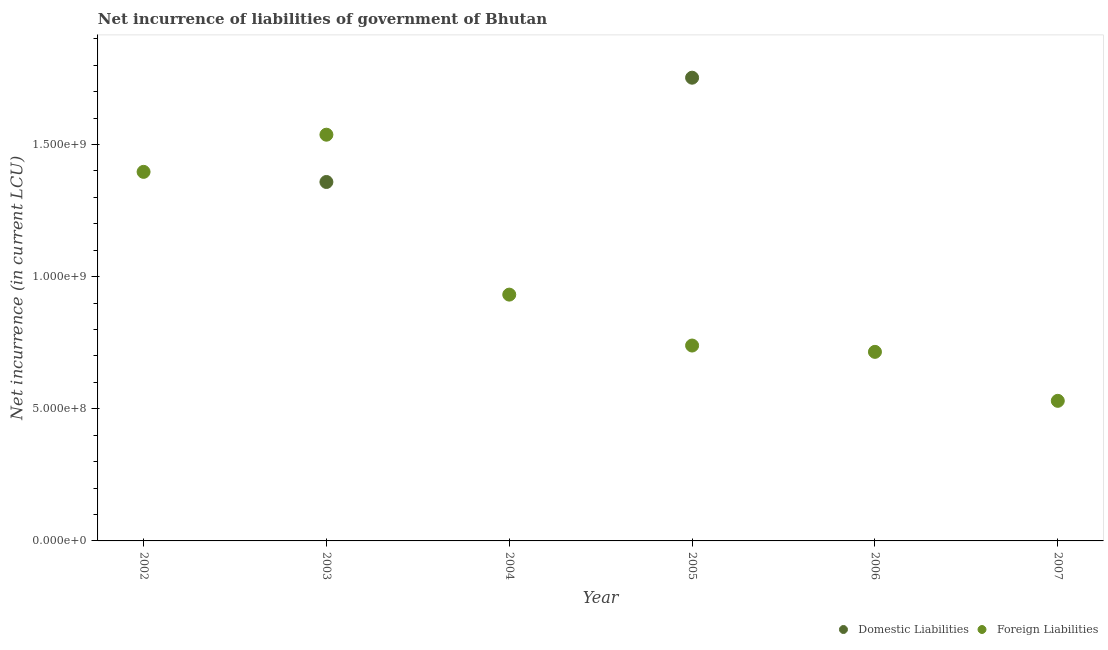How many different coloured dotlines are there?
Offer a very short reply. 2. Is the number of dotlines equal to the number of legend labels?
Offer a very short reply. No. Across all years, what is the maximum net incurrence of domestic liabilities?
Your answer should be compact. 1.75e+09. Across all years, what is the minimum net incurrence of foreign liabilities?
Your answer should be very brief. 5.30e+08. What is the total net incurrence of foreign liabilities in the graph?
Your answer should be compact. 5.85e+09. What is the difference between the net incurrence of foreign liabilities in 2003 and that in 2006?
Make the answer very short. 8.22e+08. What is the difference between the net incurrence of domestic liabilities in 2002 and the net incurrence of foreign liabilities in 2005?
Offer a terse response. -7.39e+08. What is the average net incurrence of foreign liabilities per year?
Keep it short and to the point. 9.75e+08. In the year 2003, what is the difference between the net incurrence of domestic liabilities and net incurrence of foreign liabilities?
Your response must be concise. -1.79e+08. In how many years, is the net incurrence of domestic liabilities greater than 700000000 LCU?
Provide a short and direct response. 2. What is the ratio of the net incurrence of foreign liabilities in 2004 to that in 2005?
Ensure brevity in your answer.  1.26. What is the difference between the highest and the second highest net incurrence of foreign liabilities?
Keep it short and to the point. 1.41e+08. What is the difference between the highest and the lowest net incurrence of domestic liabilities?
Keep it short and to the point. 1.75e+09. In how many years, is the net incurrence of foreign liabilities greater than the average net incurrence of foreign liabilities taken over all years?
Your answer should be compact. 2. Is the sum of the net incurrence of foreign liabilities in 2003 and 2004 greater than the maximum net incurrence of domestic liabilities across all years?
Offer a very short reply. Yes. Are the values on the major ticks of Y-axis written in scientific E-notation?
Make the answer very short. Yes. Does the graph contain grids?
Your response must be concise. No. What is the title of the graph?
Keep it short and to the point. Net incurrence of liabilities of government of Bhutan. Does "Female" appear as one of the legend labels in the graph?
Your response must be concise. No. What is the label or title of the Y-axis?
Your answer should be very brief. Net incurrence (in current LCU). What is the Net incurrence (in current LCU) in Foreign Liabilities in 2002?
Your response must be concise. 1.40e+09. What is the Net incurrence (in current LCU) in Domestic Liabilities in 2003?
Your answer should be compact. 1.36e+09. What is the Net incurrence (in current LCU) in Foreign Liabilities in 2003?
Your response must be concise. 1.54e+09. What is the Net incurrence (in current LCU) in Foreign Liabilities in 2004?
Ensure brevity in your answer.  9.32e+08. What is the Net incurrence (in current LCU) in Domestic Liabilities in 2005?
Provide a succinct answer. 1.75e+09. What is the Net incurrence (in current LCU) of Foreign Liabilities in 2005?
Your response must be concise. 7.39e+08. What is the Net incurrence (in current LCU) in Foreign Liabilities in 2006?
Your answer should be compact. 7.15e+08. What is the Net incurrence (in current LCU) of Domestic Liabilities in 2007?
Offer a terse response. 0. What is the Net incurrence (in current LCU) of Foreign Liabilities in 2007?
Your answer should be compact. 5.30e+08. Across all years, what is the maximum Net incurrence (in current LCU) of Domestic Liabilities?
Provide a short and direct response. 1.75e+09. Across all years, what is the maximum Net incurrence (in current LCU) of Foreign Liabilities?
Your response must be concise. 1.54e+09. Across all years, what is the minimum Net incurrence (in current LCU) in Domestic Liabilities?
Provide a short and direct response. 0. Across all years, what is the minimum Net incurrence (in current LCU) in Foreign Liabilities?
Provide a succinct answer. 5.30e+08. What is the total Net incurrence (in current LCU) of Domestic Liabilities in the graph?
Ensure brevity in your answer.  3.11e+09. What is the total Net incurrence (in current LCU) of Foreign Liabilities in the graph?
Give a very brief answer. 5.85e+09. What is the difference between the Net incurrence (in current LCU) of Foreign Liabilities in 2002 and that in 2003?
Give a very brief answer. -1.41e+08. What is the difference between the Net incurrence (in current LCU) of Foreign Liabilities in 2002 and that in 2004?
Offer a terse response. 4.65e+08. What is the difference between the Net incurrence (in current LCU) of Foreign Liabilities in 2002 and that in 2005?
Your answer should be very brief. 6.57e+08. What is the difference between the Net incurrence (in current LCU) in Foreign Liabilities in 2002 and that in 2006?
Provide a short and direct response. 6.81e+08. What is the difference between the Net incurrence (in current LCU) in Foreign Liabilities in 2002 and that in 2007?
Your answer should be very brief. 8.67e+08. What is the difference between the Net incurrence (in current LCU) of Foreign Liabilities in 2003 and that in 2004?
Your answer should be compact. 6.05e+08. What is the difference between the Net incurrence (in current LCU) of Domestic Liabilities in 2003 and that in 2005?
Your answer should be very brief. -3.95e+08. What is the difference between the Net incurrence (in current LCU) in Foreign Liabilities in 2003 and that in 2005?
Your response must be concise. 7.98e+08. What is the difference between the Net incurrence (in current LCU) in Foreign Liabilities in 2003 and that in 2006?
Provide a short and direct response. 8.22e+08. What is the difference between the Net incurrence (in current LCU) in Foreign Liabilities in 2003 and that in 2007?
Make the answer very short. 1.01e+09. What is the difference between the Net incurrence (in current LCU) of Foreign Liabilities in 2004 and that in 2005?
Keep it short and to the point. 1.93e+08. What is the difference between the Net incurrence (in current LCU) in Foreign Liabilities in 2004 and that in 2006?
Provide a succinct answer. 2.17e+08. What is the difference between the Net incurrence (in current LCU) of Foreign Liabilities in 2004 and that in 2007?
Your answer should be compact. 4.02e+08. What is the difference between the Net incurrence (in current LCU) of Foreign Liabilities in 2005 and that in 2006?
Provide a succinct answer. 2.39e+07. What is the difference between the Net incurrence (in current LCU) in Foreign Liabilities in 2005 and that in 2007?
Your response must be concise. 2.09e+08. What is the difference between the Net incurrence (in current LCU) in Foreign Liabilities in 2006 and that in 2007?
Keep it short and to the point. 1.85e+08. What is the difference between the Net incurrence (in current LCU) of Domestic Liabilities in 2003 and the Net incurrence (in current LCU) of Foreign Liabilities in 2004?
Keep it short and to the point. 4.26e+08. What is the difference between the Net incurrence (in current LCU) in Domestic Liabilities in 2003 and the Net incurrence (in current LCU) in Foreign Liabilities in 2005?
Provide a short and direct response. 6.19e+08. What is the difference between the Net incurrence (in current LCU) in Domestic Liabilities in 2003 and the Net incurrence (in current LCU) in Foreign Liabilities in 2006?
Provide a succinct answer. 6.43e+08. What is the difference between the Net incurrence (in current LCU) in Domestic Liabilities in 2003 and the Net incurrence (in current LCU) in Foreign Liabilities in 2007?
Offer a terse response. 8.28e+08. What is the difference between the Net incurrence (in current LCU) in Domestic Liabilities in 2005 and the Net incurrence (in current LCU) in Foreign Liabilities in 2006?
Give a very brief answer. 1.04e+09. What is the difference between the Net incurrence (in current LCU) of Domestic Liabilities in 2005 and the Net incurrence (in current LCU) of Foreign Liabilities in 2007?
Make the answer very short. 1.22e+09. What is the average Net incurrence (in current LCU) of Domestic Liabilities per year?
Your answer should be very brief. 5.19e+08. What is the average Net incurrence (in current LCU) of Foreign Liabilities per year?
Provide a succinct answer. 9.75e+08. In the year 2003, what is the difference between the Net incurrence (in current LCU) in Domestic Liabilities and Net incurrence (in current LCU) in Foreign Liabilities?
Offer a terse response. -1.79e+08. In the year 2005, what is the difference between the Net incurrence (in current LCU) of Domestic Liabilities and Net incurrence (in current LCU) of Foreign Liabilities?
Your response must be concise. 1.01e+09. What is the ratio of the Net incurrence (in current LCU) of Foreign Liabilities in 2002 to that in 2003?
Ensure brevity in your answer.  0.91. What is the ratio of the Net incurrence (in current LCU) of Foreign Liabilities in 2002 to that in 2004?
Your response must be concise. 1.5. What is the ratio of the Net incurrence (in current LCU) of Foreign Liabilities in 2002 to that in 2005?
Offer a terse response. 1.89. What is the ratio of the Net incurrence (in current LCU) of Foreign Liabilities in 2002 to that in 2006?
Your response must be concise. 1.95. What is the ratio of the Net incurrence (in current LCU) of Foreign Liabilities in 2002 to that in 2007?
Make the answer very short. 2.63. What is the ratio of the Net incurrence (in current LCU) of Foreign Liabilities in 2003 to that in 2004?
Make the answer very short. 1.65. What is the ratio of the Net incurrence (in current LCU) of Domestic Liabilities in 2003 to that in 2005?
Your answer should be compact. 0.77. What is the ratio of the Net incurrence (in current LCU) in Foreign Liabilities in 2003 to that in 2005?
Provide a short and direct response. 2.08. What is the ratio of the Net incurrence (in current LCU) of Foreign Liabilities in 2003 to that in 2006?
Offer a very short reply. 2.15. What is the ratio of the Net incurrence (in current LCU) in Foreign Liabilities in 2003 to that in 2007?
Offer a very short reply. 2.9. What is the ratio of the Net incurrence (in current LCU) in Foreign Liabilities in 2004 to that in 2005?
Offer a terse response. 1.26. What is the ratio of the Net incurrence (in current LCU) of Foreign Liabilities in 2004 to that in 2006?
Provide a short and direct response. 1.3. What is the ratio of the Net incurrence (in current LCU) of Foreign Liabilities in 2004 to that in 2007?
Provide a short and direct response. 1.76. What is the ratio of the Net incurrence (in current LCU) of Foreign Liabilities in 2005 to that in 2006?
Your answer should be very brief. 1.03. What is the ratio of the Net incurrence (in current LCU) in Foreign Liabilities in 2005 to that in 2007?
Offer a terse response. 1.39. What is the ratio of the Net incurrence (in current LCU) of Foreign Liabilities in 2006 to that in 2007?
Your answer should be very brief. 1.35. What is the difference between the highest and the second highest Net incurrence (in current LCU) of Foreign Liabilities?
Your answer should be very brief. 1.41e+08. What is the difference between the highest and the lowest Net incurrence (in current LCU) in Domestic Liabilities?
Provide a short and direct response. 1.75e+09. What is the difference between the highest and the lowest Net incurrence (in current LCU) in Foreign Liabilities?
Your response must be concise. 1.01e+09. 